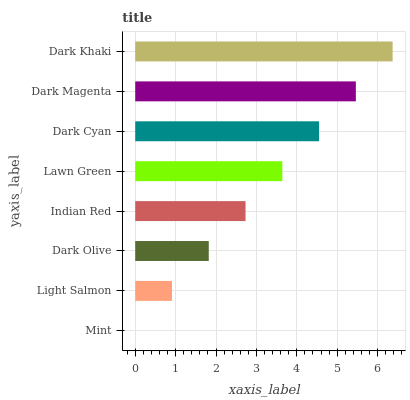Is Mint the minimum?
Answer yes or no. Yes. Is Dark Khaki the maximum?
Answer yes or no. Yes. Is Light Salmon the minimum?
Answer yes or no. No. Is Light Salmon the maximum?
Answer yes or no. No. Is Light Salmon greater than Mint?
Answer yes or no. Yes. Is Mint less than Light Salmon?
Answer yes or no. Yes. Is Mint greater than Light Salmon?
Answer yes or no. No. Is Light Salmon less than Mint?
Answer yes or no. No. Is Lawn Green the high median?
Answer yes or no. Yes. Is Indian Red the low median?
Answer yes or no. Yes. Is Dark Olive the high median?
Answer yes or no. No. Is Lawn Green the low median?
Answer yes or no. No. 